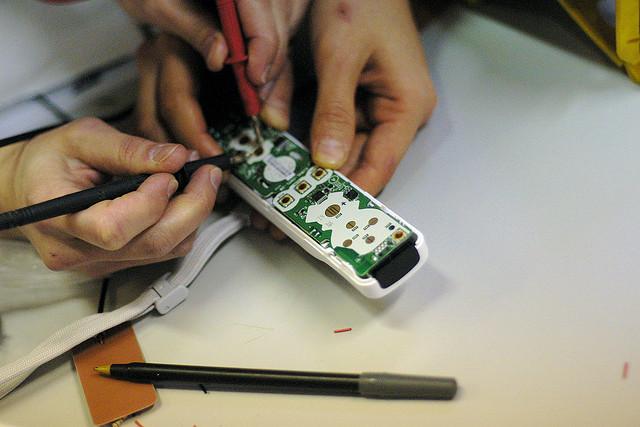What do they mean by "Green"?
Write a very short answer. Color. Can the markers stain the table?
Answer briefly. Yes. Are those dangerous?
Be succinct. No. What objects are on the table in the picture?
Quick response, please. Pen. What is the red tool being used?
Short answer required. Screwdriver. What is this equipment used for?
Concise answer only. Wii. What are the hands using?
Concise answer only. Tools. What color ink does the pen likely write in?
Keep it brief. Black. Is there a towel on the table?
Short answer required. No. What is in the people's hands?
Quick response, please. Remote. 